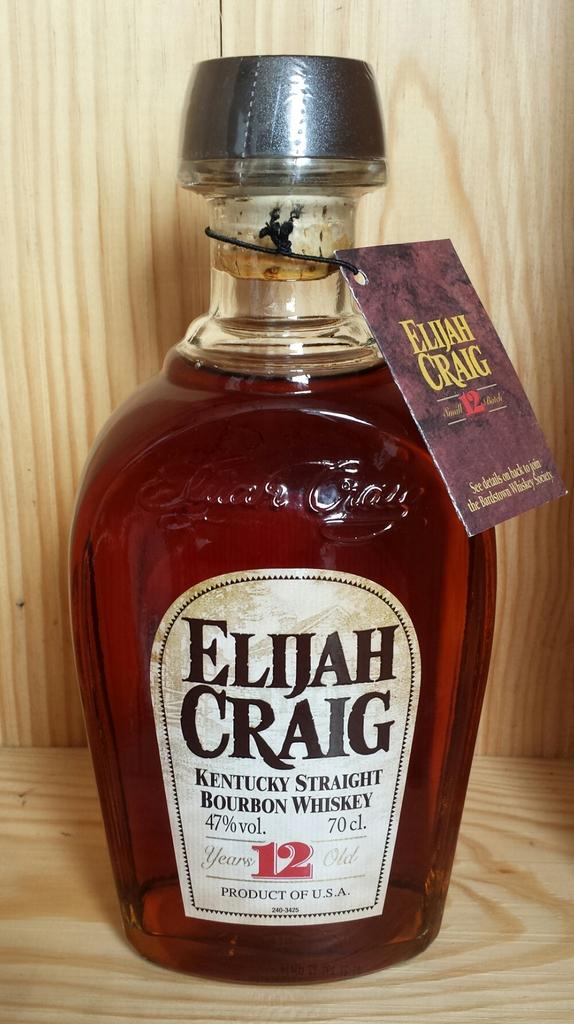What is the brand name of this whiskey?
Your answer should be very brief. Elijah craig. How old is this whiskey?
Your answer should be compact. 12 years. 